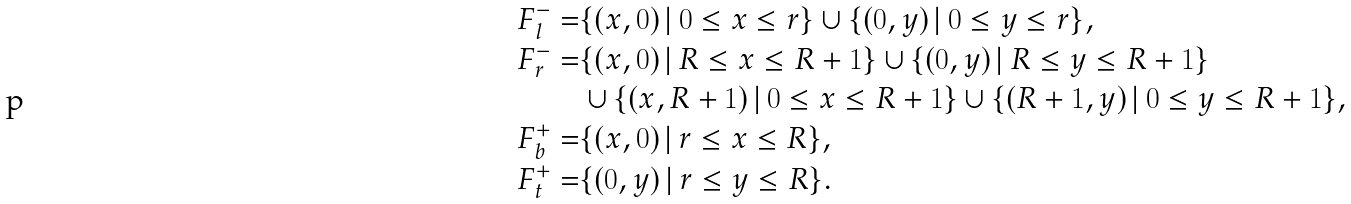<formula> <loc_0><loc_0><loc_500><loc_500>F _ { l } ^ { - } = & \{ ( x , 0 ) \, | \, 0 \leq x \leq r \} \cup \{ ( 0 , y ) \, | \, 0 \leq y \leq r \} , \\ F _ { r } ^ { - } = & \{ ( x , 0 ) \, | \, R \leq x \leq R + 1 \} \cup \{ ( 0 , y ) \, | \, R \leq y \leq R + 1 \} \\ & \cup \{ ( x , R + 1 ) \, | \, 0 \leq x \leq R + 1 \} \cup \{ ( R + 1 , y ) \, | \, 0 \leq y \leq R + 1 \} , \\ F _ { b } ^ { + } = & \{ ( x , 0 ) \, | \, r \leq x \leq R \} , \\ F _ { t } ^ { + } = & \{ ( 0 , y ) \, | \, r \leq y \leq R \} .</formula> 